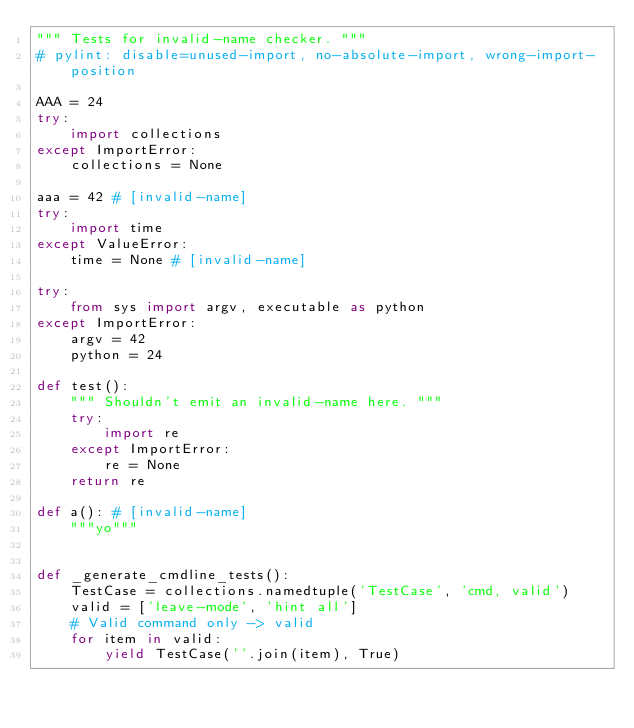<code> <loc_0><loc_0><loc_500><loc_500><_Python_>""" Tests for invalid-name checker. """
# pylint: disable=unused-import, no-absolute-import, wrong-import-position

AAA = 24
try:
    import collections
except ImportError:
    collections = None

aaa = 42 # [invalid-name]
try:
    import time
except ValueError:
    time = None # [invalid-name]

try:
    from sys import argv, executable as python
except ImportError:
    argv = 42
    python = 24

def test():
    """ Shouldn't emit an invalid-name here. """
    try:
        import re
    except ImportError:
        re = None
    return re

def a(): # [invalid-name]
    """yo"""


def _generate_cmdline_tests():
    TestCase = collections.namedtuple('TestCase', 'cmd, valid')
    valid = ['leave-mode', 'hint all']
    # Valid command only -> valid
    for item in valid:
        yield TestCase(''.join(item), True)
</code> 